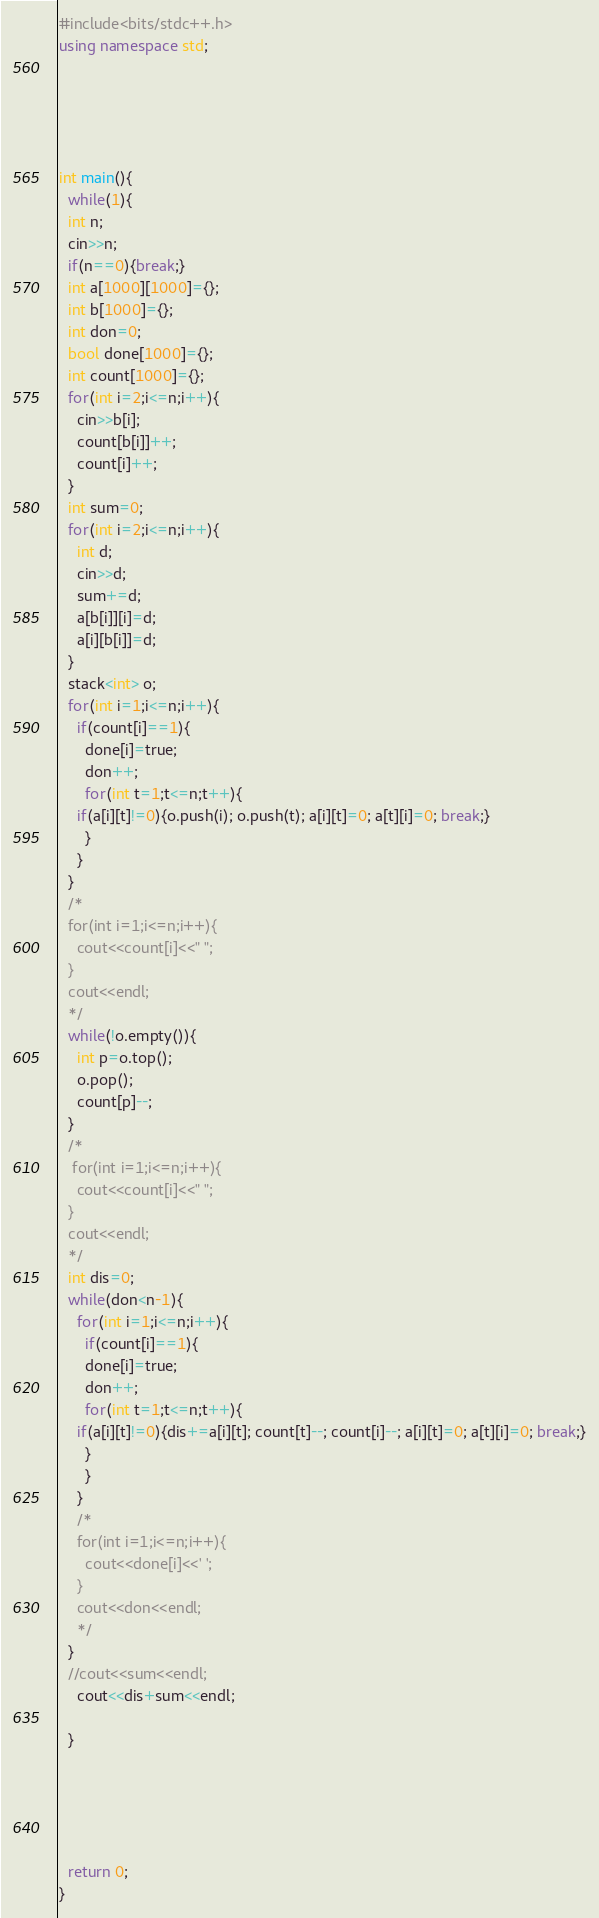Convert code to text. <code><loc_0><loc_0><loc_500><loc_500><_C++_>#include<bits/stdc++.h>
using namespace std;





int main(){
  while(1){
  int n;
  cin>>n;
  if(n==0){break;}
  int a[1000][1000]={};
  int b[1000]={};
  int don=0;
  bool done[1000]={};
  int count[1000]={};
  for(int i=2;i<=n;i++){
    cin>>b[i];
    count[b[i]]++;
    count[i]++;
  }
  int sum=0;
  for(int i=2;i<=n;i++){
    int d;
    cin>>d;
    sum+=d;
    a[b[i]][i]=d;
    a[i][b[i]]=d;
  }
  stack<int> o;
  for(int i=1;i<=n;i++){
    if(count[i]==1){
      done[i]=true;
      don++;
      for(int t=1;t<=n;t++){
	if(a[i][t]!=0){o.push(i); o.push(t); a[i][t]=0; a[t][i]=0; break;}
      }
    }
  }
  /*
  for(int i=1;i<=n;i++){
    cout<<count[i]<<" ";
  }
  cout<<endl;
  */
  while(!o.empty()){
    int p=o.top();
    o.pop();
    count[p]--;
  }
  /*
   for(int i=1;i<=n;i++){
    cout<<count[i]<<" ";
  }
  cout<<endl;
  */
  int dis=0;
  while(don<n-1){
    for(int i=1;i<=n;i++){
      if(count[i]==1){
      done[i]=true;
      don++;
      for(int t=1;t<=n;t++){
	if(a[i][t]!=0){dis+=a[i][t]; count[t]--; count[i]--; a[i][t]=0; a[t][i]=0; break;}
      }
      }
    }
    /*
    for(int i=1;i<=n;i++){
      cout<<done[i]<<' ';
    }
    cout<<don<<endl;
    */
  }
  //cout<<sum<<endl;
    cout<<dis+sum<<endl;

  }
  
  
  
  
  
  return 0;
}

</code> 